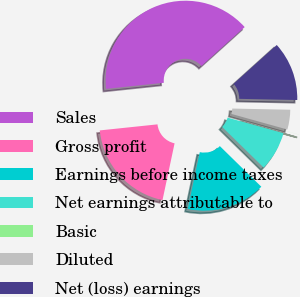Convert chart. <chart><loc_0><loc_0><loc_500><loc_500><pie_chart><fcel>Sales<fcel>Gross profit<fcel>Earnings before income taxes<fcel>Net earnings attributable to<fcel>Basic<fcel>Diluted<fcel>Net (loss) earnings<nl><fcel>39.99%<fcel>20.0%<fcel>16.0%<fcel>8.0%<fcel>0.01%<fcel>4.0%<fcel>12.0%<nl></chart> 